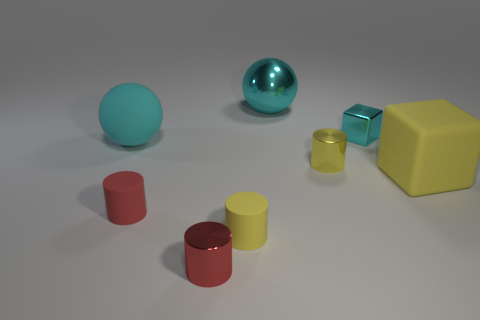Is there any other thing that is the same color as the small shiny cube?
Offer a very short reply. Yes. The cube that is behind the big rubber thing that is in front of the large rubber object that is behind the large yellow thing is what color?
Provide a succinct answer. Cyan. Does the red rubber cylinder have the same size as the rubber block?
Give a very brief answer. No. How many red objects are the same size as the yellow rubber block?
Ensure brevity in your answer.  0. The metallic thing that is the same color as the rubber cube is what shape?
Provide a succinct answer. Cylinder. Are the yellow cylinder behind the red rubber thing and the object behind the cyan block made of the same material?
Make the answer very short. Yes. Is there anything else that has the same shape as the tiny cyan metallic object?
Your answer should be very brief. Yes. What is the color of the large metallic ball?
Provide a succinct answer. Cyan. What number of other large things are the same shape as the cyan matte object?
Your answer should be very brief. 1. What is the color of the rubber object that is the same size as the matte cube?
Your response must be concise. Cyan. 